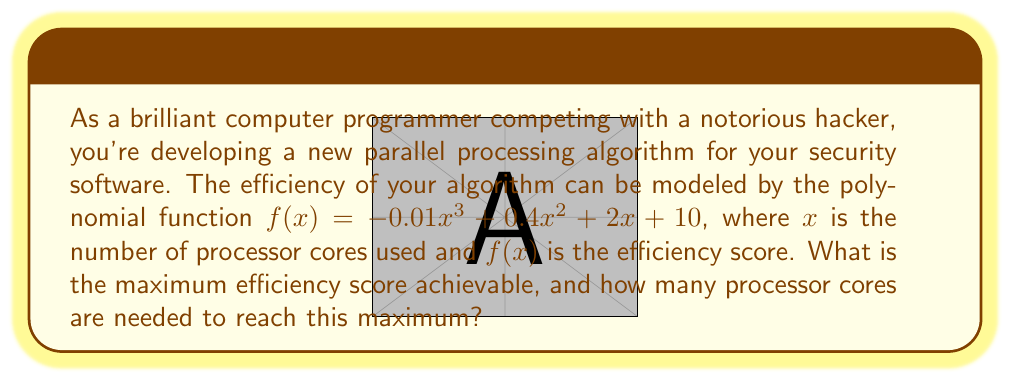Could you help me with this problem? To solve this problem, we need to follow these steps:

1) The maximum efficiency score will occur at the vertex of the polynomial function. Since this is a cubic function with a negative leading coefficient, it will have a local maximum.

2) To find the vertex, we need to find the derivative of the function and set it equal to zero:

   $f'(x) = -0.03x^2 + 0.8x + 2$

3) Set $f'(x) = 0$:

   $-0.03x^2 + 0.8x + 2 = 0$

4) This is a quadratic equation. We can solve it using the quadratic formula:

   $x = \frac{-b \pm \sqrt{b^2 - 4ac}}{2a}$

   Where $a = -0.03$, $b = 0.8$, and $c = 2$

5) Plugging in these values:

   $x = \frac{-0.8 \pm \sqrt{0.8^2 - 4(-0.03)(2)}}{2(-0.03)}$

6) Simplifying:

   $x = \frac{-0.8 \pm \sqrt{0.64 + 0.24}}{-0.06} = \frac{-0.8 \pm \sqrt{0.88}}{-0.06} = \frac{-0.8 \pm 0.9381}{-0.06}$

7) This gives us two solutions:
   
   $x_1 = \frac{-0.8 + 0.9381}{-0.06} \approx 2.30$
   $x_2 = \frac{-0.8 - 0.9381}{-0.06} \approx 29.03$

8) Since we're looking for a maximum, we choose the value between these two: $x \approx 29.03$

9) Round this to the nearest whole number of cores: 29 cores

10) To find the maximum efficiency score, plug this value back into the original function:

    $f(29) = -0.01(29)^3 + 0.4(29)^2 + 2(29) + 10$
           $= -243.49 + 336.4 + 58 + 10$
           $= 160.91$

Therefore, the maximum efficiency score is approximately 160.91, achieved with 29 processor cores.
Answer: Maximum efficiency score: 160.91
Number of processor cores needed: 29 